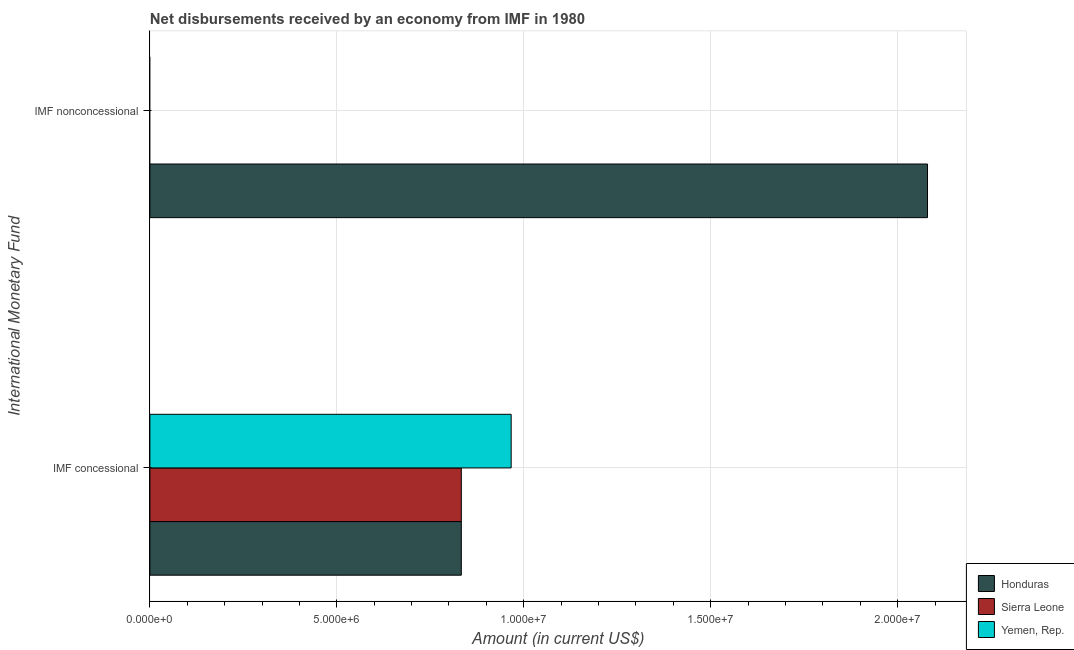How many different coloured bars are there?
Provide a short and direct response. 3. Are the number of bars per tick equal to the number of legend labels?
Offer a terse response. No. How many bars are there on the 1st tick from the bottom?
Offer a terse response. 3. What is the label of the 1st group of bars from the top?
Your answer should be very brief. IMF nonconcessional. Across all countries, what is the maximum net concessional disbursements from imf?
Provide a short and direct response. 9.66e+06. Across all countries, what is the minimum net concessional disbursements from imf?
Keep it short and to the point. 8.33e+06. In which country was the net concessional disbursements from imf maximum?
Give a very brief answer. Yemen, Rep. What is the total net concessional disbursements from imf in the graph?
Your answer should be compact. 2.63e+07. What is the difference between the net concessional disbursements from imf in Sierra Leone and the net non concessional disbursements from imf in Honduras?
Your response must be concise. -1.25e+07. What is the average net non concessional disbursements from imf per country?
Ensure brevity in your answer.  6.93e+06. What is the difference between the net non concessional disbursements from imf and net concessional disbursements from imf in Honduras?
Ensure brevity in your answer.  1.25e+07. What is the ratio of the net concessional disbursements from imf in Yemen, Rep. to that in Honduras?
Provide a short and direct response. 1.16. Is the net concessional disbursements from imf in Yemen, Rep. less than that in Sierra Leone?
Give a very brief answer. No. How many bars are there?
Offer a terse response. 4. Are all the bars in the graph horizontal?
Give a very brief answer. Yes. Are the values on the major ticks of X-axis written in scientific E-notation?
Make the answer very short. Yes. Does the graph contain any zero values?
Ensure brevity in your answer.  Yes. Where does the legend appear in the graph?
Your response must be concise. Bottom right. What is the title of the graph?
Your response must be concise. Net disbursements received by an economy from IMF in 1980. What is the label or title of the Y-axis?
Give a very brief answer. International Monetary Fund. What is the Amount (in current US$) in Honduras in IMF concessional?
Give a very brief answer. 8.33e+06. What is the Amount (in current US$) in Sierra Leone in IMF concessional?
Offer a terse response. 8.33e+06. What is the Amount (in current US$) in Yemen, Rep. in IMF concessional?
Ensure brevity in your answer.  9.66e+06. What is the Amount (in current US$) in Honduras in IMF nonconcessional?
Your response must be concise. 2.08e+07. What is the Amount (in current US$) of Yemen, Rep. in IMF nonconcessional?
Offer a terse response. 0. Across all International Monetary Fund, what is the maximum Amount (in current US$) of Honduras?
Offer a very short reply. 2.08e+07. Across all International Monetary Fund, what is the maximum Amount (in current US$) in Sierra Leone?
Your answer should be very brief. 8.33e+06. Across all International Monetary Fund, what is the maximum Amount (in current US$) in Yemen, Rep.?
Your response must be concise. 9.66e+06. Across all International Monetary Fund, what is the minimum Amount (in current US$) in Honduras?
Your answer should be compact. 8.33e+06. Across all International Monetary Fund, what is the minimum Amount (in current US$) of Sierra Leone?
Keep it short and to the point. 0. What is the total Amount (in current US$) of Honduras in the graph?
Provide a succinct answer. 2.91e+07. What is the total Amount (in current US$) of Sierra Leone in the graph?
Offer a terse response. 8.33e+06. What is the total Amount (in current US$) of Yemen, Rep. in the graph?
Keep it short and to the point. 9.66e+06. What is the difference between the Amount (in current US$) in Honduras in IMF concessional and that in IMF nonconcessional?
Offer a very short reply. -1.25e+07. What is the average Amount (in current US$) of Honduras per International Monetary Fund?
Keep it short and to the point. 1.46e+07. What is the average Amount (in current US$) of Sierra Leone per International Monetary Fund?
Offer a terse response. 4.16e+06. What is the average Amount (in current US$) of Yemen, Rep. per International Monetary Fund?
Ensure brevity in your answer.  4.83e+06. What is the difference between the Amount (in current US$) of Honduras and Amount (in current US$) of Yemen, Rep. in IMF concessional?
Make the answer very short. -1.33e+06. What is the difference between the Amount (in current US$) in Sierra Leone and Amount (in current US$) in Yemen, Rep. in IMF concessional?
Provide a succinct answer. -1.33e+06. What is the ratio of the Amount (in current US$) in Honduras in IMF concessional to that in IMF nonconcessional?
Offer a terse response. 0.4. What is the difference between the highest and the second highest Amount (in current US$) of Honduras?
Ensure brevity in your answer.  1.25e+07. What is the difference between the highest and the lowest Amount (in current US$) of Honduras?
Make the answer very short. 1.25e+07. What is the difference between the highest and the lowest Amount (in current US$) of Sierra Leone?
Offer a terse response. 8.33e+06. What is the difference between the highest and the lowest Amount (in current US$) of Yemen, Rep.?
Your answer should be compact. 9.66e+06. 